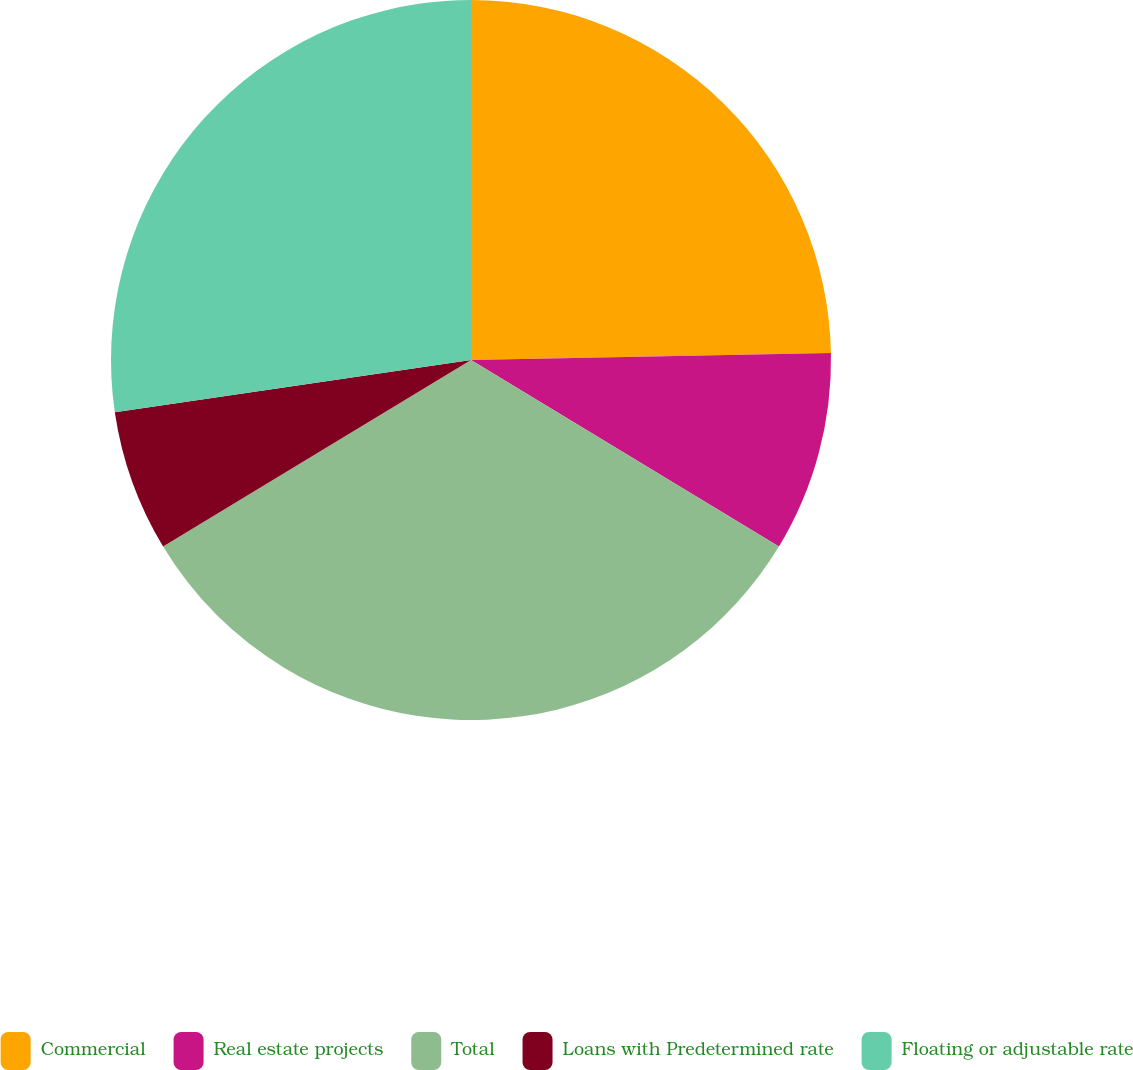Convert chart. <chart><loc_0><loc_0><loc_500><loc_500><pie_chart><fcel>Commercial<fcel>Real estate projects<fcel>Total<fcel>Loans with Predetermined rate<fcel>Floating or adjustable rate<nl><fcel>24.69%<fcel>8.98%<fcel>32.66%<fcel>6.35%<fcel>27.32%<nl></chart> 